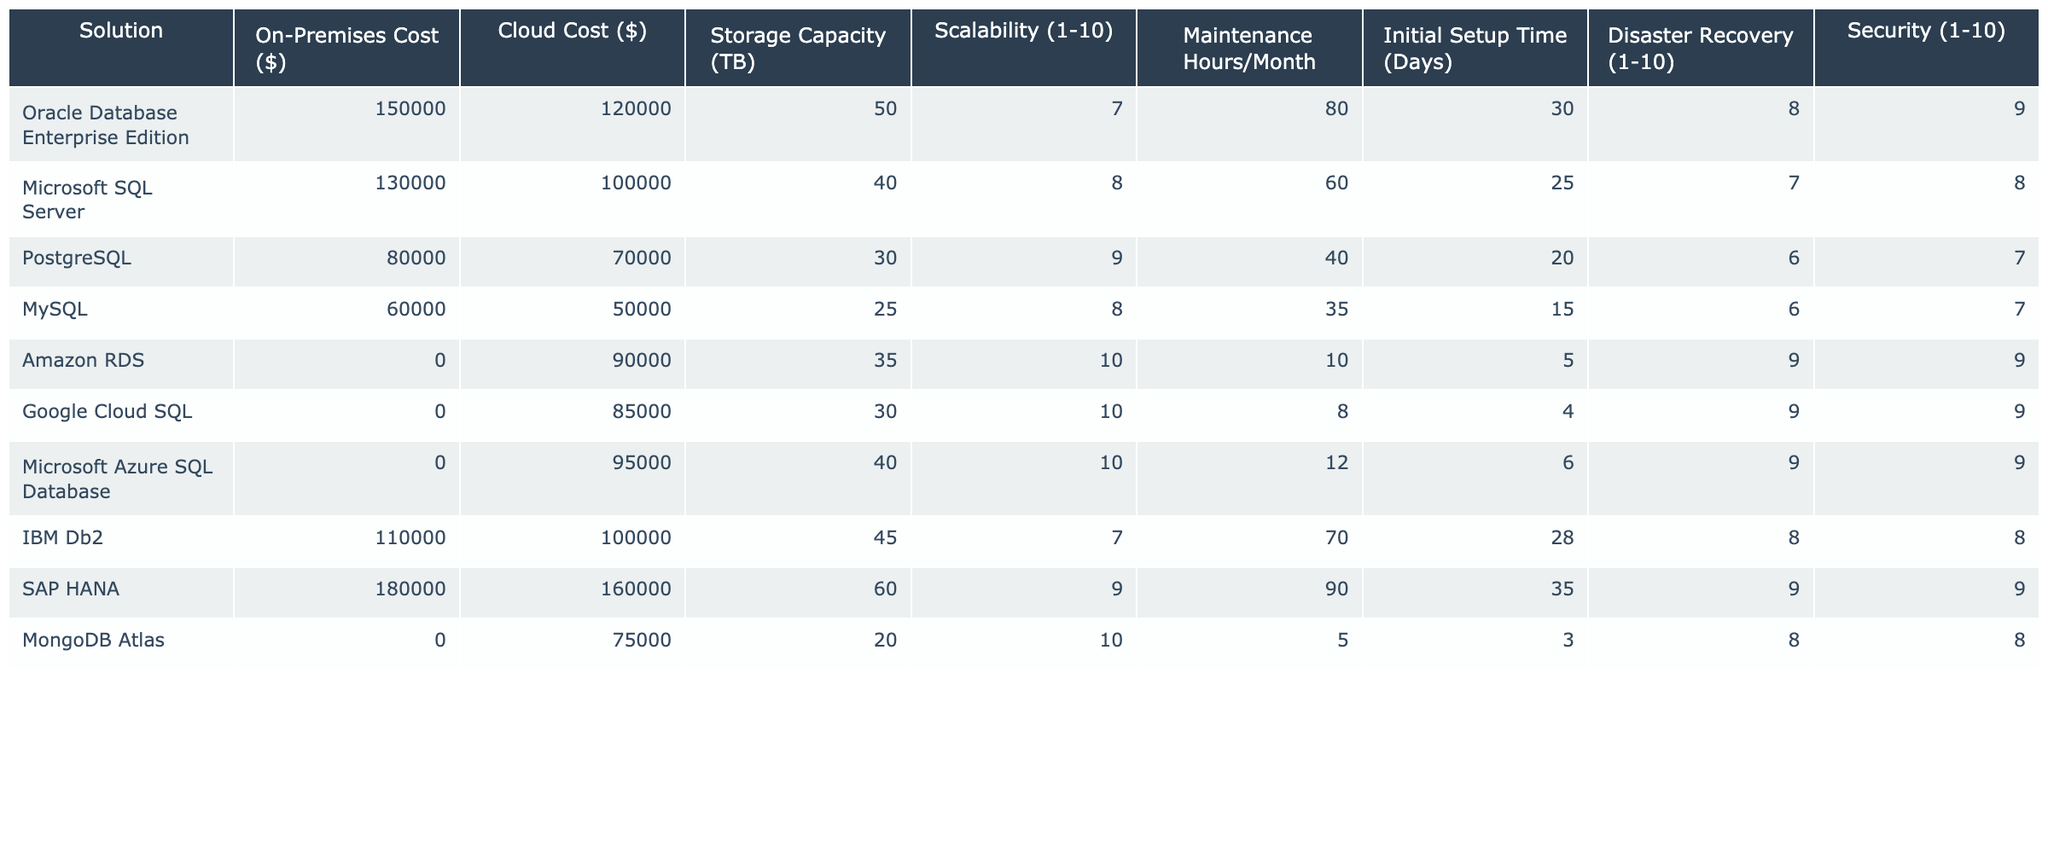What is the cost of Oracle Database Enterprise Edition on-premises? The table indicates that the on-premises cost for Oracle Database Enterprise Edition is listed as 150,000.
Answer: 150000 What is the storage capacity of the Google Cloud SQL solution? According to the table, Google Cloud SQL has a storage capacity of 30 TB.
Answer: 30 TB Which database solution has the highest scalability rating? Looking at the scalability ratings in the table, Amazon RDS, Google Cloud SQL, and Microsoft Azure SQL Database all have a rating of 10, which is the highest.
Answer: Amazon RDS, Google Cloud SQL, and Microsoft Azure SQL Database What is the initial setup time for PostgreSQL? The table reveals that the initial setup time for PostgreSQL is 20 days.
Answer: 20 days Which solution has the lowest maintenance hours per month? When reviewing the maintenance hours per month, the table shows that Amazon RDS requires only 10 hours. This is the least compared to other solutions.
Answer: 10 hours What is the average cloud cost across all solutions? To find the average cloud cost: (120000 + 100000 + 70000 + 50000 + 90000 + 85000 + 95000 + 100000 + 160000 + 75000) = 1000000. Dividing by the number of solutions (10) gives us an average of 100000.
Answer: 100000 Does MongoDB Atlas provide a higher on-premises cost than PostgreSQL? The table shows that MongoDB Atlas has an on-premises cost of 0, while PostgreSQL has an on-premises cost of 80,000. Therefore, MongoDB Atlas does not provide a higher on-premises cost than PostgreSQL.
Answer: No How does the disaster recovery rating of MySQL compare to that of IBM Db2? MySQL has a disaster recovery rating of 6, while IBM Db2's rating is 8. Since 6 is less than 8, IBM Db2 has a better disaster recovery rating than MySQL.
Answer: IBM Db2 has a better disaster recovery rating What is the difference in cost between SAP HANA and Microsoft SQL Server for cloud-based solutions? The cloud cost for SAP HANA is 160,000 and for Microsoft SQL Server is 100,000. The difference is calculated by subtracting the latter from the former: 160,000 - 100,000 = 60,000.
Answer: 60000 Which database has the highest on-premises cost and what is that cost? Upon checking the on-premises costs in the table, SAP HANA has the highest cost at 180,000.
Answer: 180000 